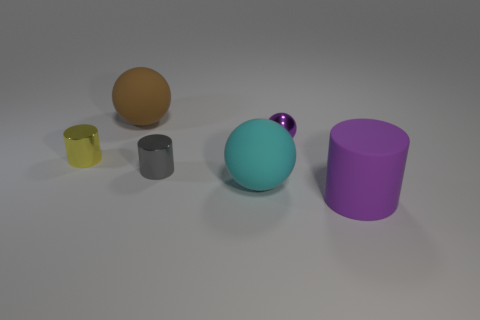What material is the tiny gray cylinder?
Ensure brevity in your answer.  Metal. There is a tiny thing that is on the right side of the big brown sphere and in front of the small purple thing; what material is it made of?
Offer a very short reply. Metal. How many objects are cylinders right of the small metal ball or small gray blocks?
Provide a short and direct response. 1. Do the metallic sphere and the matte cylinder have the same color?
Offer a very short reply. Yes. Is there a cyan matte thing of the same size as the brown matte object?
Give a very brief answer. Yes. What number of tiny metallic objects are right of the yellow metal thing and in front of the purple ball?
Ensure brevity in your answer.  1. How many big purple rubber things are left of the purple shiny object?
Your answer should be compact. 0. Is there a gray object that has the same shape as the yellow metal thing?
Offer a terse response. Yes. Is the shape of the purple rubber object the same as the small metallic thing to the left of the brown matte thing?
Keep it short and to the point. Yes. What number of cubes are either small cyan objects or small yellow objects?
Provide a short and direct response. 0. 